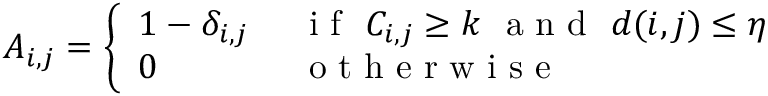Convert formula to latex. <formula><loc_0><loc_0><loc_500><loc_500>A _ { i , j } = \left \{ \begin{array} { l l } { 1 - \delta _ { i , j } } & { i f C _ { i , j } \geq k a n d d ( i , j ) \leq \eta } \\ { 0 } & { o t h e r w i s e } \end{array}</formula> 